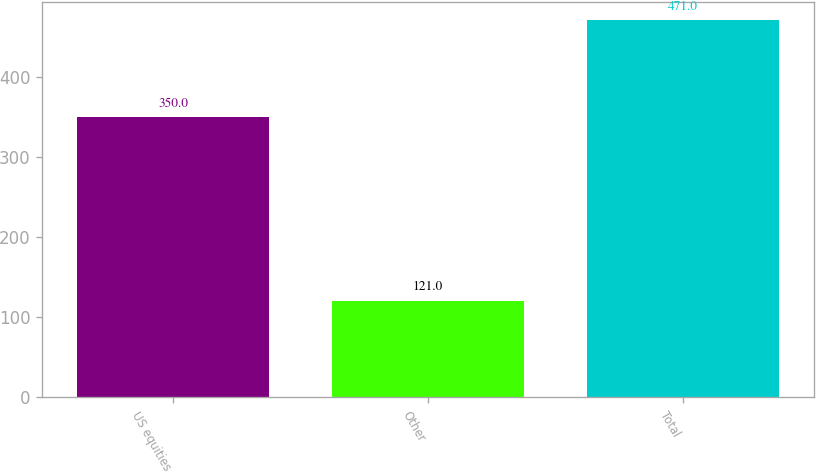Convert chart. <chart><loc_0><loc_0><loc_500><loc_500><bar_chart><fcel>US equities<fcel>Other<fcel>Total<nl><fcel>350<fcel>121<fcel>471<nl></chart> 